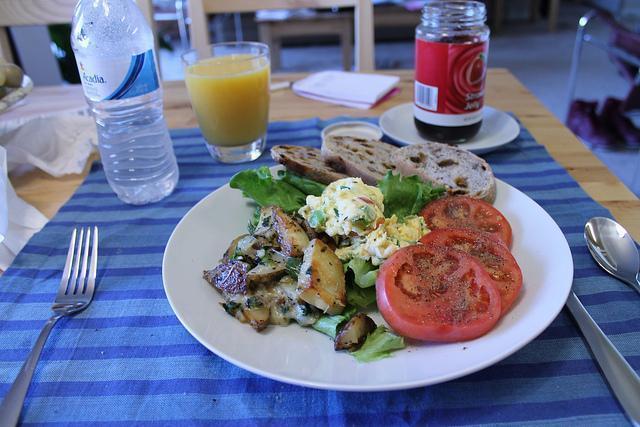How many chairs are in the picture?
Give a very brief answer. 2. How many bottles are there?
Give a very brief answer. 2. 